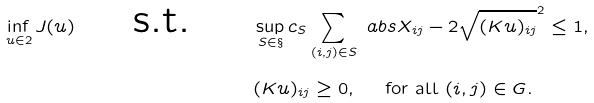Convert formula to latex. <formula><loc_0><loc_0><loc_500><loc_500>\inf _ { u \in \L { 2 } } J ( u ) \quad \text { s.t. } \quad & \sup _ { S \in \S } c _ { S } \sum _ { ( i , j ) \in S } \ a b s { X _ { i j } - 2 \sqrt { ( K u ) _ { i j } } } ^ { 2 } \leq 1 , \\ & ( K u ) _ { i j } \geq 0 , \quad \text { for all } ( i , j ) \in G .</formula> 